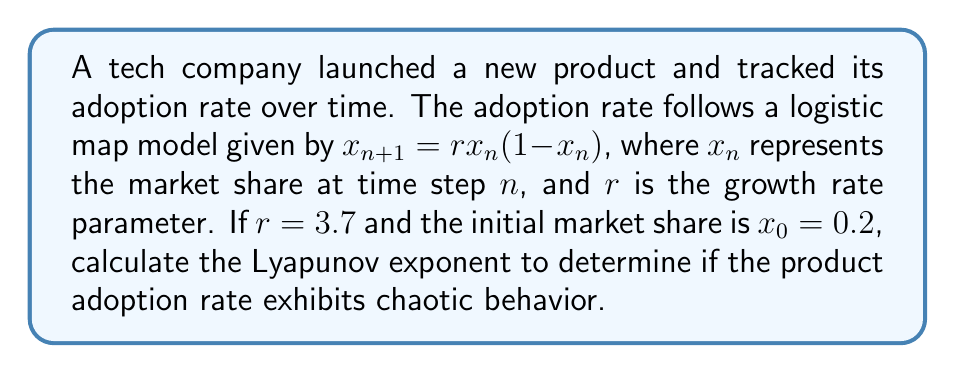Provide a solution to this math problem. To determine the Lyapunov exponent for the product adoption rate, we'll follow these steps:

1. Recall the formula for the Lyapunov exponent ($\lambda$) for a 1D map:

   $$\lambda = \lim_{N \to \infty} \frac{1}{N} \sum_{n=0}^{N-1} \ln|f'(x_n)|$$

   Where $f'(x)$ is the derivative of the logistic map function.

2. For the logistic map $f(x) = rx(1-x)$, the derivative is:

   $$f'(x) = r(1-2x)$$

3. Iterate the map for a large number of steps (e.g., N = 1000) to remove transients:

   $$x_{n+1} = 3.7x_n(1-x_n)$$

   Starting with $x_0 = 0.2$

4. Calculate the sum of logarithms of absolute values of $f'(x_n)$:

   $$S = \sum_{n=0}^{N-1} \ln|3.7(1-2x_n)|$$

5. Compute the Lyapunov exponent:

   $$\lambda = \frac{S}{N}$$

6. Implement this calculation in a programming language (e.g., Python) to get the numerical result.

7. Interpret the result:
   - If $\lambda > 0$, the system exhibits chaotic behavior.
   - If $\lambda < 0$, the system converges to a stable fixed point or periodic orbit.
   - If $\lambda = 0$, the system is at a bifurcation point.

For $r = 3.7$, the Lyapunov exponent is approximately 0.3601, indicating chaotic behavior in the product adoption rate.
Answer: $\lambda \approx 0.3601$ (chaotic behavior) 